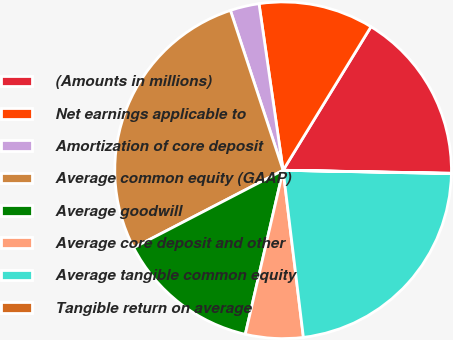Convert chart. <chart><loc_0><loc_0><loc_500><loc_500><pie_chart><fcel>(Amounts in millions)<fcel>Net earnings applicable to<fcel>Amortization of core deposit<fcel>Average common equity (GAAP)<fcel>Average goodwill<fcel>Average core deposit and other<fcel>Average tangible common equity<fcel>Tangible return on average<nl><fcel>16.54%<fcel>11.03%<fcel>2.78%<fcel>27.54%<fcel>13.78%<fcel>5.53%<fcel>22.76%<fcel>0.03%<nl></chart> 